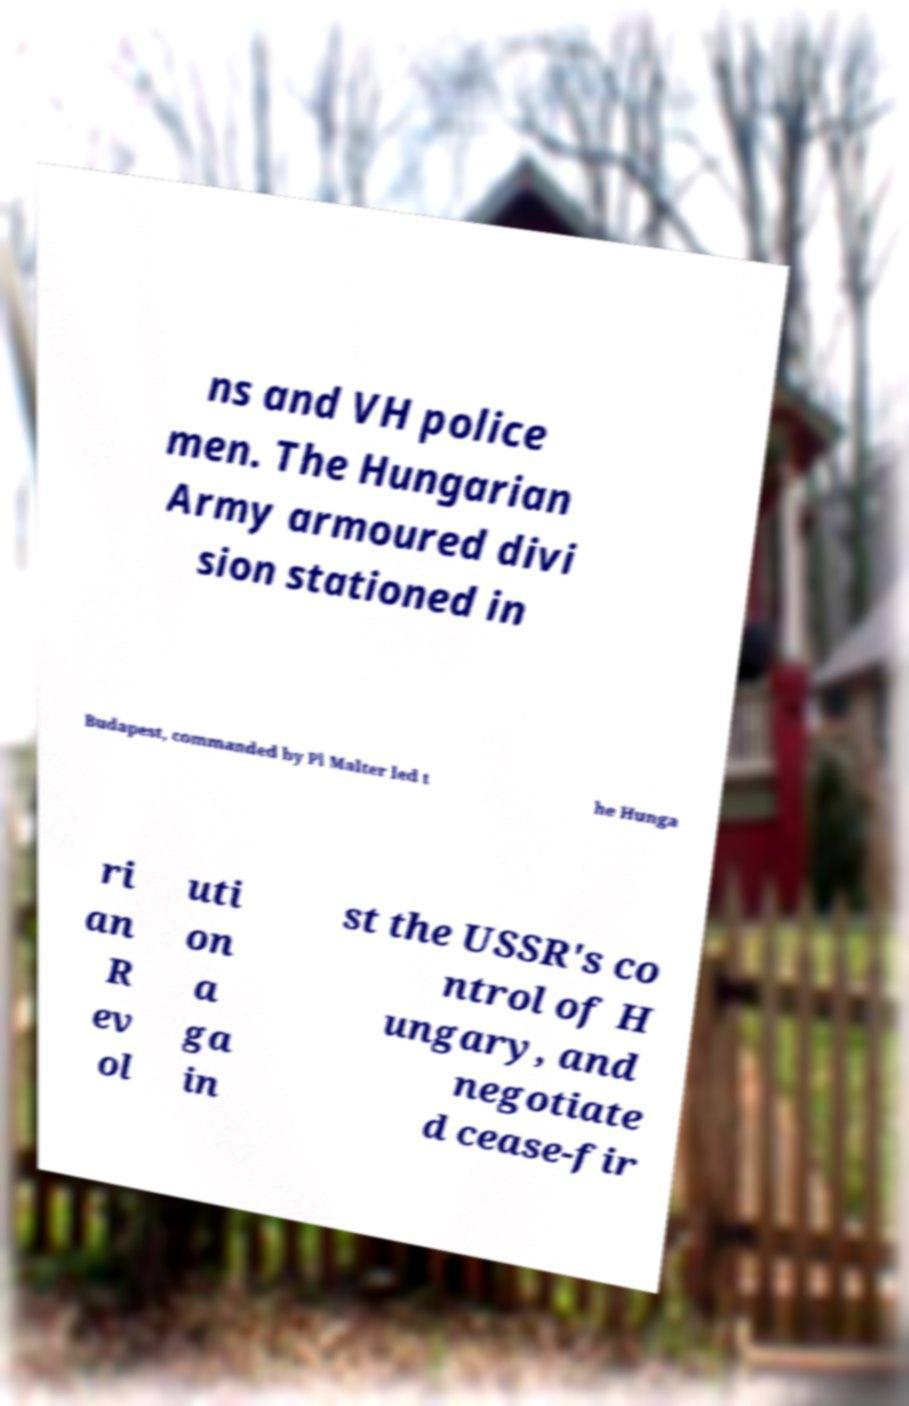Please read and relay the text visible in this image. What does it say? ns and VH police men. The Hungarian Army armoured divi sion stationed in Budapest, commanded by Pl Malter led t he Hunga ri an R ev ol uti on a ga in st the USSR's co ntrol of H ungary, and negotiate d cease-fir 